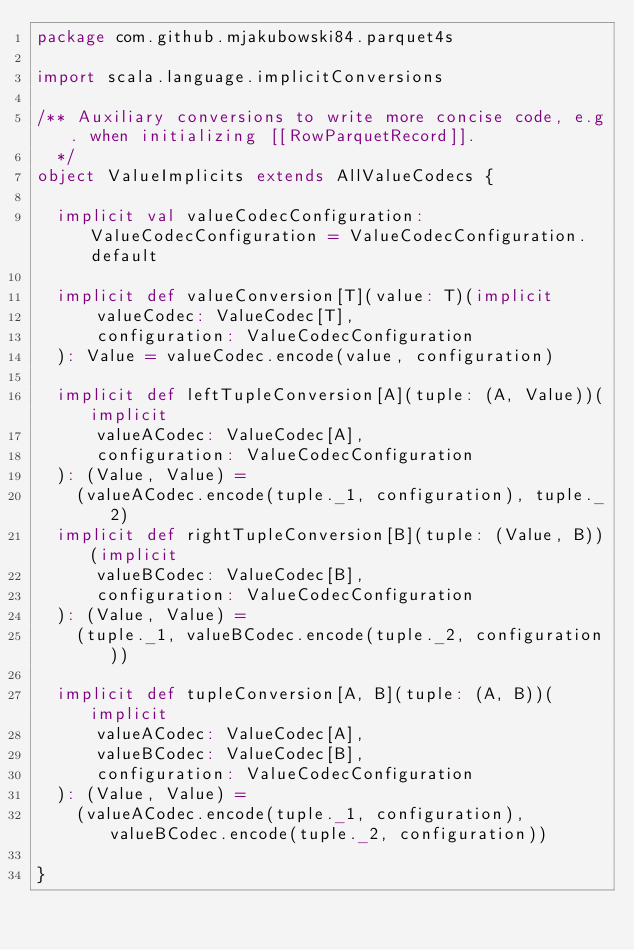Convert code to text. <code><loc_0><loc_0><loc_500><loc_500><_Scala_>package com.github.mjakubowski84.parquet4s

import scala.language.implicitConversions

/** Auxiliary conversions to write more concise code, e.g. when initializing [[RowParquetRecord]].
  */
object ValueImplicits extends AllValueCodecs {

  implicit val valueCodecConfiguration: ValueCodecConfiguration = ValueCodecConfiguration.default

  implicit def valueConversion[T](value: T)(implicit
      valueCodec: ValueCodec[T],
      configuration: ValueCodecConfiguration
  ): Value = valueCodec.encode(value, configuration)

  implicit def leftTupleConversion[A](tuple: (A, Value))(implicit
      valueACodec: ValueCodec[A],
      configuration: ValueCodecConfiguration
  ): (Value, Value) =
    (valueACodec.encode(tuple._1, configuration), tuple._2)
  implicit def rightTupleConversion[B](tuple: (Value, B))(implicit
      valueBCodec: ValueCodec[B],
      configuration: ValueCodecConfiguration
  ): (Value, Value) =
    (tuple._1, valueBCodec.encode(tuple._2, configuration))

  implicit def tupleConversion[A, B](tuple: (A, B))(implicit
      valueACodec: ValueCodec[A],
      valueBCodec: ValueCodec[B],
      configuration: ValueCodecConfiguration
  ): (Value, Value) =
    (valueACodec.encode(tuple._1, configuration), valueBCodec.encode(tuple._2, configuration))

}
</code> 